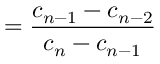Convert formula to latex. <formula><loc_0><loc_0><loc_500><loc_500>= { \frac { c _ { n - 1 } - c _ { n - 2 } } { c _ { n } - c _ { n - 1 } } }</formula> 